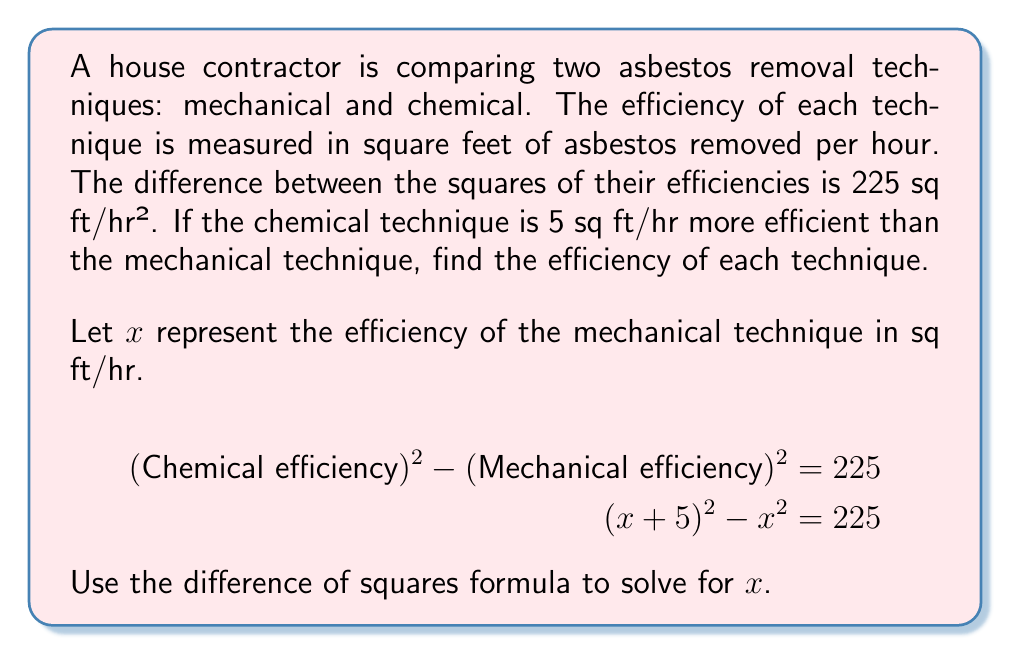Could you help me with this problem? Let's solve this step-by-step using the difference of squares formula:

1) We start with the equation: $(x+5)^2 - x^2 = 225$

2) The difference of squares formula states: $a^2 - b^2 = (a+b)(a-b)$

3) In our case, $a = x+5$ and $b = x$. Let's apply the formula:
   $((x+5) + x)((x+5) - x) = 225$

4) Simplify:
   $(2x + 5)(5) = 225$

5) Expand:
   $10x + 25 = 225$

6) Subtract 25 from both sides:
   $10x = 200$

7) Divide both sides by 10:
   $x = 20$

Therefore, the efficiency of the mechanical technique is 20 sq ft/hr.

8) The chemical technique is 5 sq ft/hr more efficient, so its efficiency is:
   $20 + 5 = 25$ sq ft/hr

9) To verify, let's check if these values satisfy the original equation:
   $(25)^2 - (20)^2 = 625 - 400 = 225$

   This confirms our solution is correct.
Answer: The efficiency of the mechanical technique is 20 sq ft/hr, and the efficiency of the chemical technique is 25 sq ft/hr. 